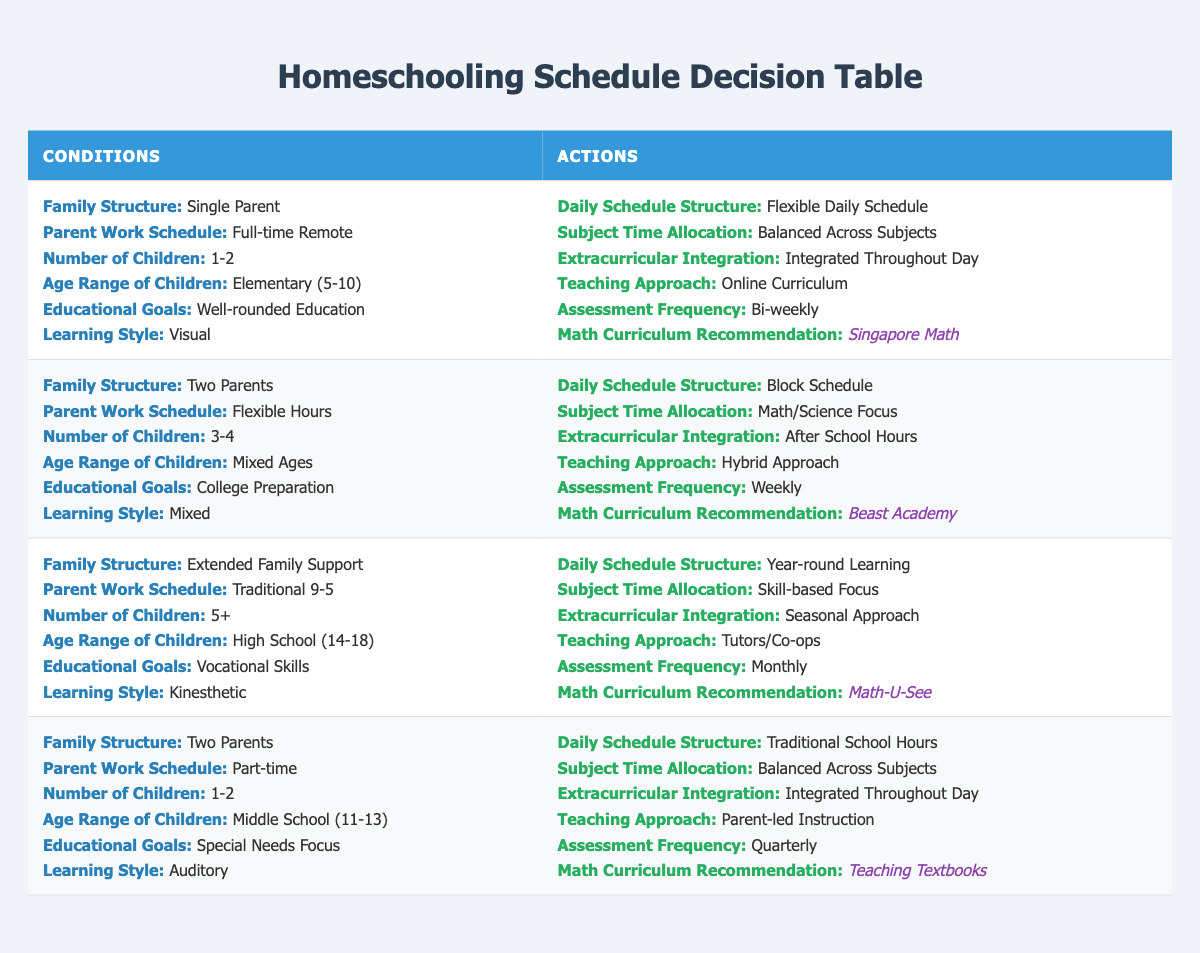What is the recommended math curriculum for a single-parent family with elementary children? The table indicates that for a single-parent family with children in the elementary age range and a well-rounded education goal, the recommended math curriculum is Singapore Math.
Answer: Singapore Math How often are assessments conducted for families with a flexible work schedule and mixed-age children? According to the table, families with two parents, a flexible work schedule, and mixed-age children conduct assessments weekly.
Answer: Weekly What is the daily schedule structure for families who are supported by extended family with high school children? The data shows that for families with extended family support, parenting a large number of high school children and focusing on vocational skills, the daily schedule structure is year-round learning.
Answer: Year-round learning Is the teaching approach for middle school children in a part-time working family parent-led instruction or online curriculum? The table specifies that for families with part-time working parents and middle school children focusing on special needs, the teaching approach is parent-led instruction.
Answer: Parent-led instruction If a family has 5 or more children and aims for vocational skills with a kinesthetic learning style, what is the subject time allocation? The table states that for families with extended family support, 5 or more children in high school focusing on vocational skills with a kinesthetic learning style, the subject time allocation is skill-based focus.
Answer: Skill-based focus How many families listed in the table have a traditional 9-5 working parent structure? There is one family in the table that fits the criteria of having a traditional 9-5 working parent structure, which is the family focusing on vocational skills with high school children.
Answer: 1 What is the extracurricular integration approach for families with 3-4 children wanting college preparation? The data indicates that families with two parents, a flexible work schedule, and 3-4 children of mixed ages who are focused on college preparation integrate extracurricular activities after school hours.
Answer: After school hours Which learning styles are associated with the recommended math curricula in the table? Upon reviewing the data, Singapore Math is associated with the visual learning style for a single-parent family, Beast Academy is associated with a mixed learning style for college preparation, Teaching Textbooks is associated with the auditory style for special needs, and Math-U-See aligns with the kinesthetic style for vocational focus.
Answer: Visual, Mixed, Auditory, Kinesthetic What are the differences in assessment frequency between families with a flexible work schedule and those with a traditional 9-5 schedule? In the table, families with a flexible work schedule for mixed-age children have assessments weekly, while the family with a traditional 9-5 schedule for high school children has assessments monthly. Therefore, the difference is weekly versus monthly.
Answer: Weekly vs. Monthly 